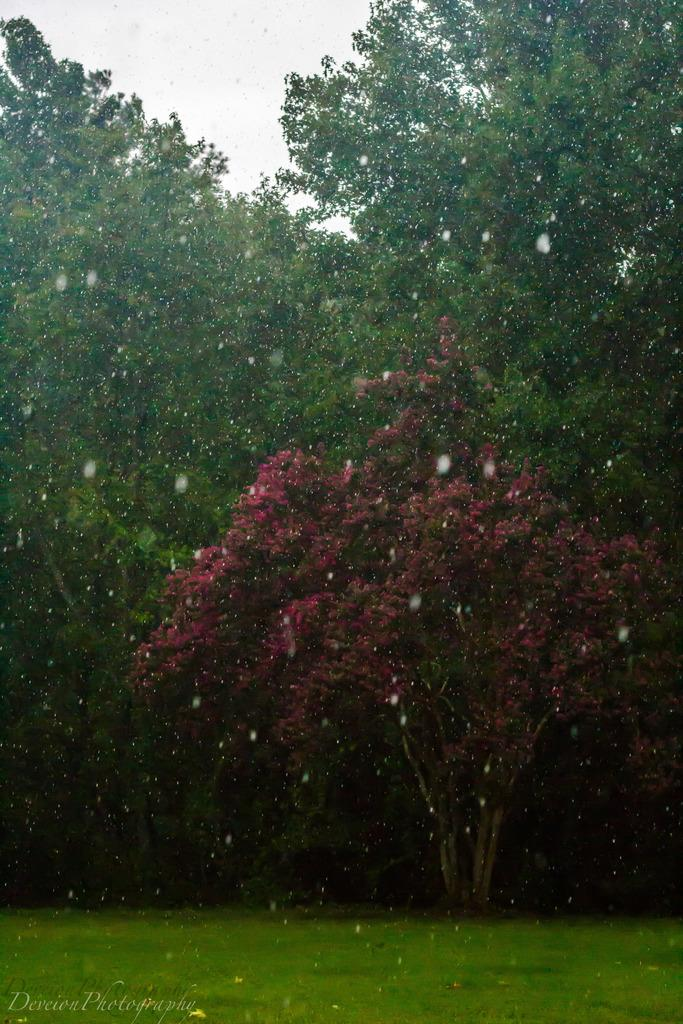What type of vegetation can be seen in the image? There are trees in the image. What type of ground cover is present in the image? There is grass in the image. What part of the natural environment is visible in the image? The sky is visible in the image. What type of tomatoes can be seen rolling on the grass in the image? There are no tomatoes present in the image, and therefore no such activity can be observed. 